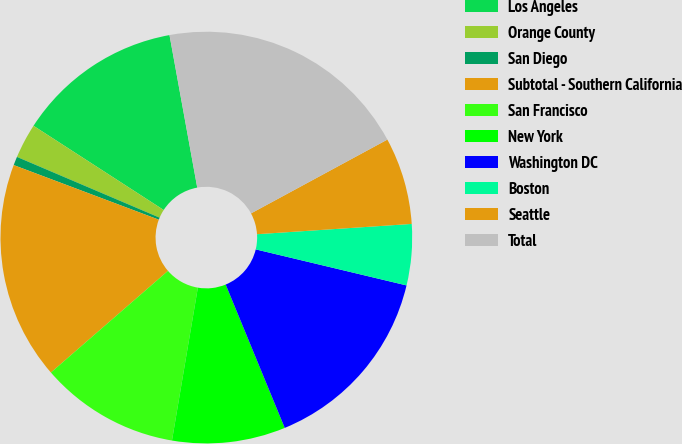Convert chart. <chart><loc_0><loc_0><loc_500><loc_500><pie_chart><fcel>Los Angeles<fcel>Orange County<fcel>San Diego<fcel>Subtotal - Southern California<fcel>San Francisco<fcel>New York<fcel>Washington DC<fcel>Boston<fcel>Seattle<fcel>Total<nl><fcel>13.0%<fcel>2.73%<fcel>0.68%<fcel>17.11%<fcel>10.95%<fcel>8.89%<fcel>15.05%<fcel>4.79%<fcel>6.84%<fcel>19.97%<nl></chart> 